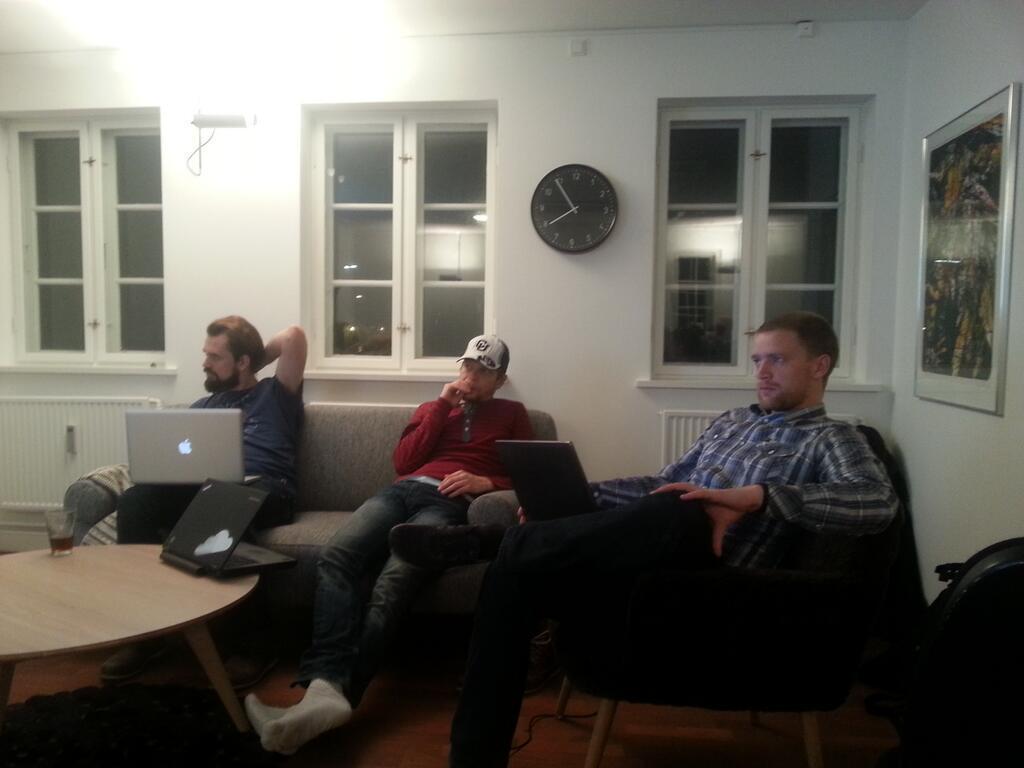Describe this image in one or two sentences. In this picture we can see three persons sitting on sofa with their laptops and in front of them there is table and on table we can see glass, laptop and in background we can see windows, watch, frame. 